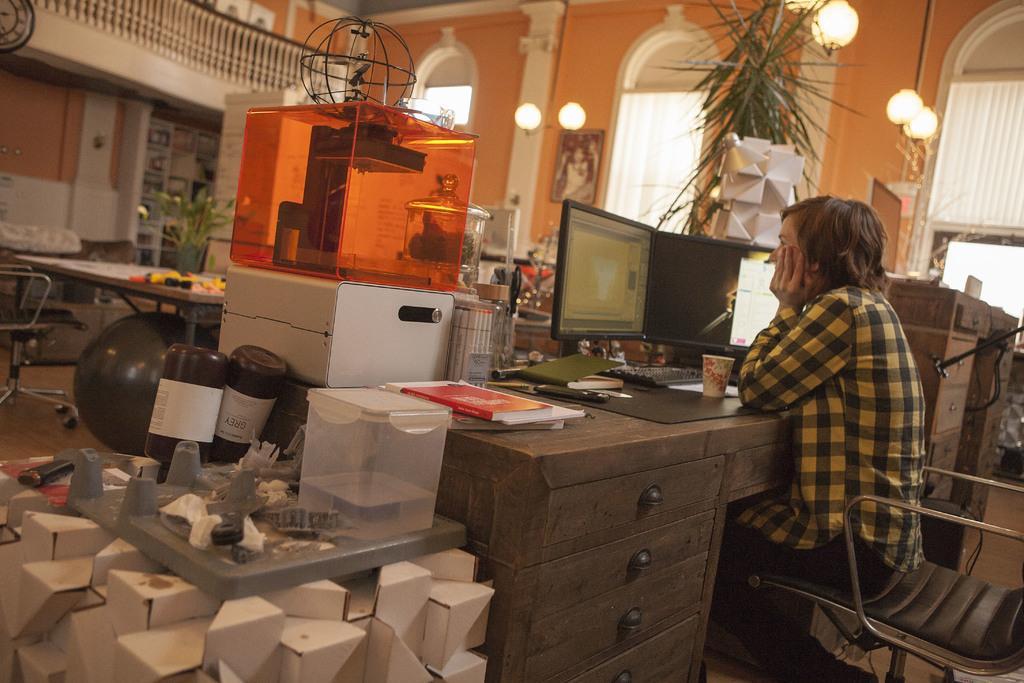How would you summarize this image in a sentence or two? In the image we can see a person sitting on a chair and looking at the system. In front of him a glass is kept. There is a plant and a air balloon. 